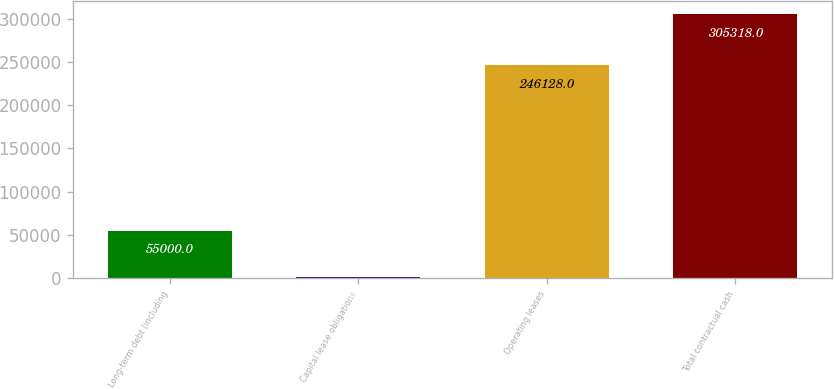<chart> <loc_0><loc_0><loc_500><loc_500><bar_chart><fcel>Long-term debt (including<fcel>Capital lease obligations<fcel>Operating leases<fcel>Total contractual cash<nl><fcel>55000<fcel>1807<fcel>246128<fcel>305318<nl></chart> 